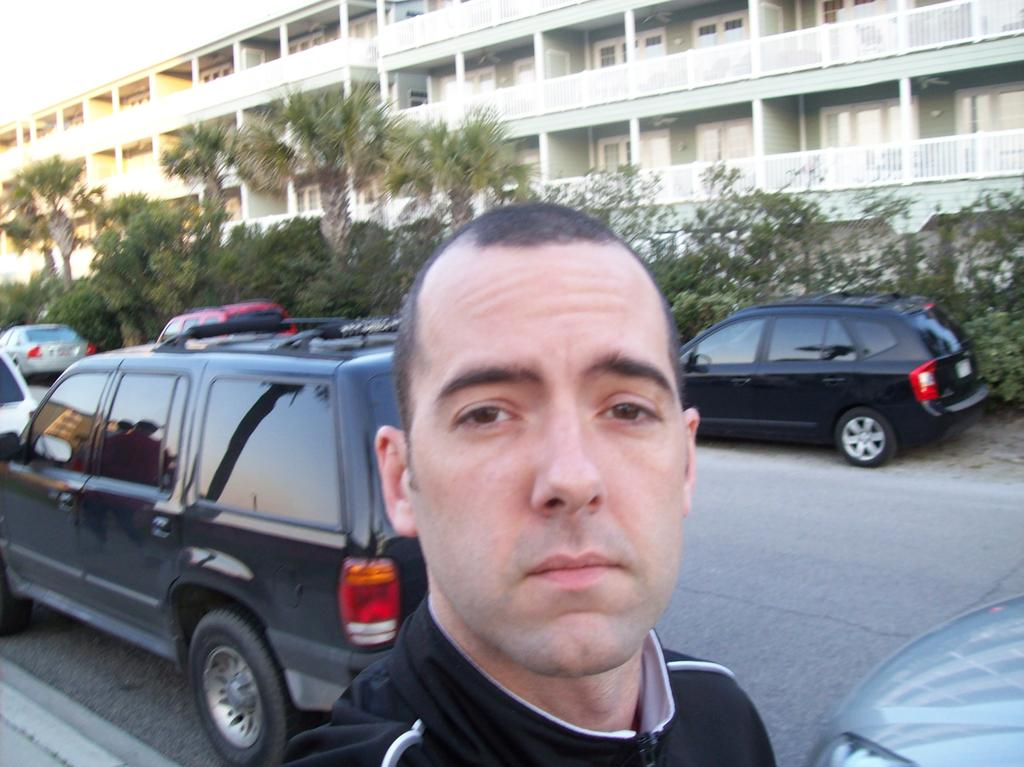Who is the main subject in the image? There is a man standing in the front of the image. What is the man doing in the image? The man is looking at the camera. What can be seen behind the man? There is a car behind the man. What is visible behind the car? There are trees behind the car. What type of structure is visible in the background of the image? There is a building with balcony grills in the background of the image. What type of question is being asked in the image? There is no question being asked in the image; it is a still photograph of a man, a car, trees, and a building. What season is depicted in the image? The provided facts do not mention any seasonal details, so it cannot be determined from the image. 